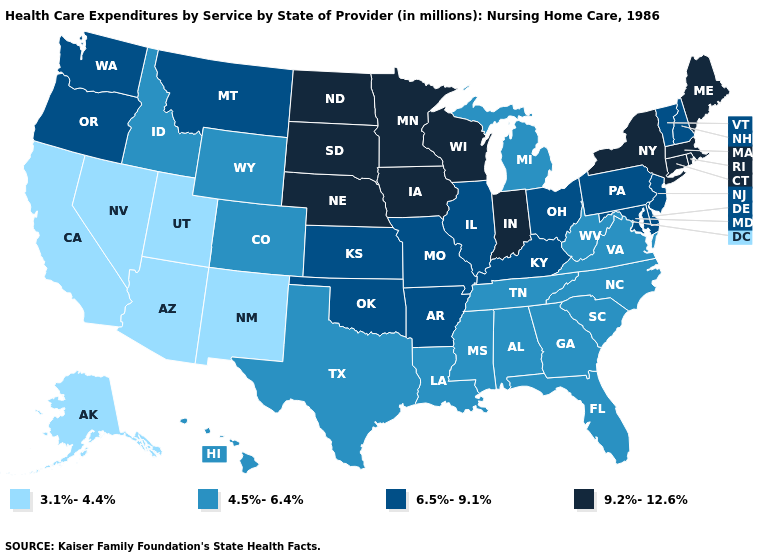Does the first symbol in the legend represent the smallest category?
Answer briefly. Yes. Does New Jersey have a higher value than Alaska?
Short answer required. Yes. Which states have the lowest value in the USA?
Quick response, please. Alaska, Arizona, California, Nevada, New Mexico, Utah. Does Connecticut have a lower value than Delaware?
Write a very short answer. No. What is the value of Oklahoma?
Concise answer only. 6.5%-9.1%. What is the value of Texas?
Short answer required. 4.5%-6.4%. Name the states that have a value in the range 3.1%-4.4%?
Keep it brief. Alaska, Arizona, California, Nevada, New Mexico, Utah. What is the lowest value in states that border Missouri?
Answer briefly. 4.5%-6.4%. Name the states that have a value in the range 3.1%-4.4%?
Answer briefly. Alaska, Arizona, California, Nevada, New Mexico, Utah. Does the map have missing data?
Write a very short answer. No. Does Connecticut have the highest value in the Northeast?
Give a very brief answer. Yes. Among the states that border Washington , which have the lowest value?
Write a very short answer. Idaho. Name the states that have a value in the range 4.5%-6.4%?
Write a very short answer. Alabama, Colorado, Florida, Georgia, Hawaii, Idaho, Louisiana, Michigan, Mississippi, North Carolina, South Carolina, Tennessee, Texas, Virginia, West Virginia, Wyoming. Name the states that have a value in the range 3.1%-4.4%?
Be succinct. Alaska, Arizona, California, Nevada, New Mexico, Utah. Which states hav the highest value in the Northeast?
Keep it brief. Connecticut, Maine, Massachusetts, New York, Rhode Island. 